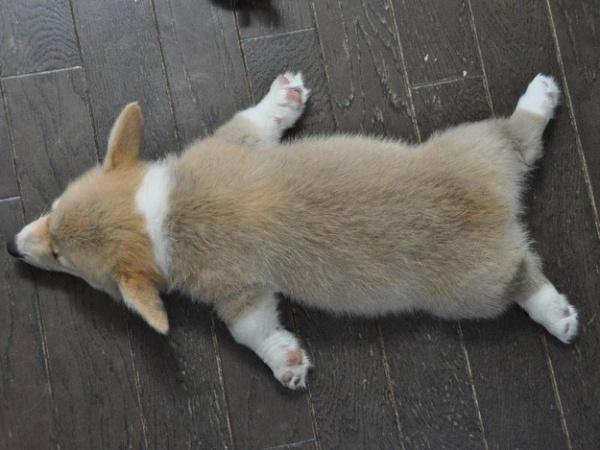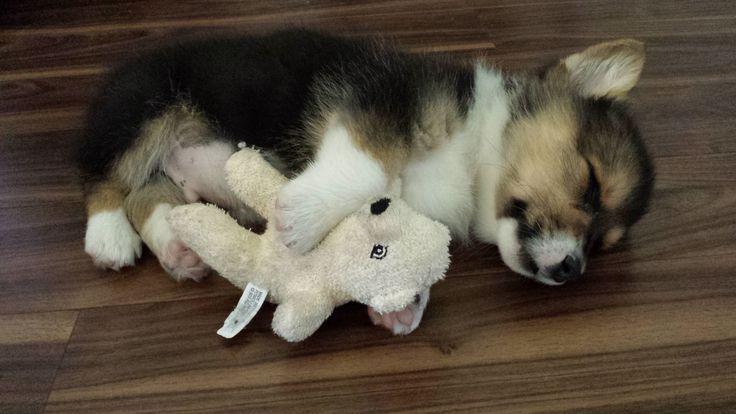The first image is the image on the left, the second image is the image on the right. Assess this claim about the two images: "All of the dogs are lying down, either on their bellies or on their backs, but not on their side.". Correct or not? Answer yes or no. No. The first image is the image on the left, the second image is the image on the right. For the images shown, is this caption "There are at least 5 dogs lying on the floor." true? Answer yes or no. No. 